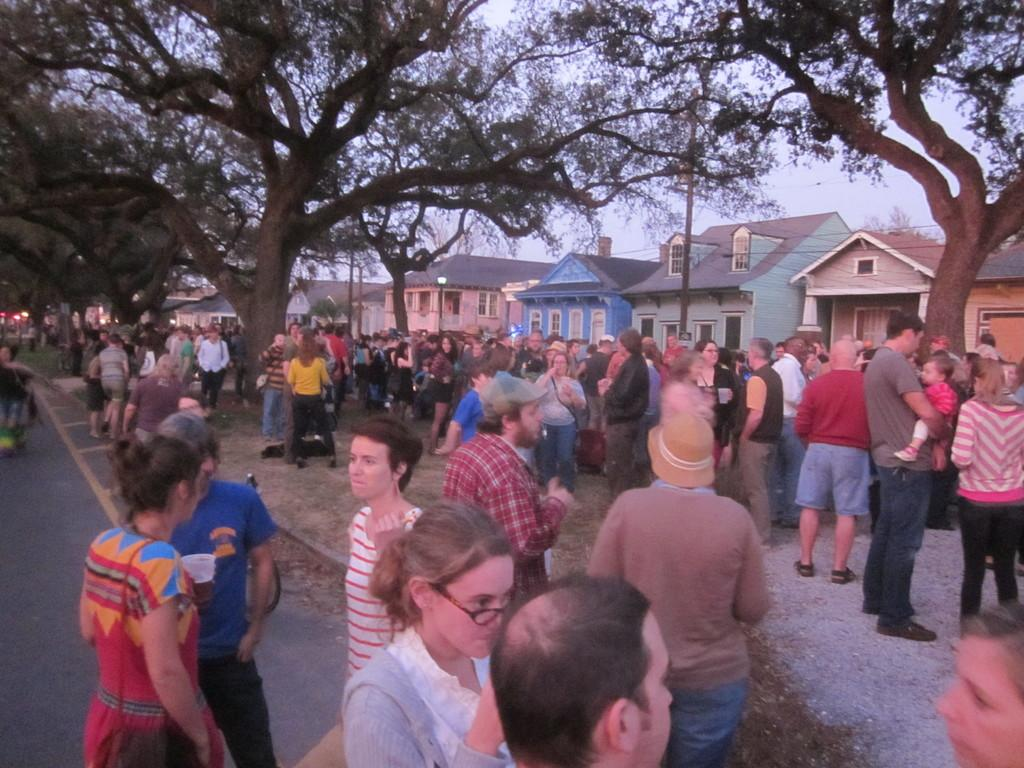What are the people in the image doing? The persons standing on the ground in the image are likely standing or interacting with each other. What type of vegetation can be seen in the image? There are trees in the image. What can be seen in the background of the image? There are buildings and the sky visible in the background of the image. How many cats are sitting on the truck in the image? There is no truck or cats present in the image. 